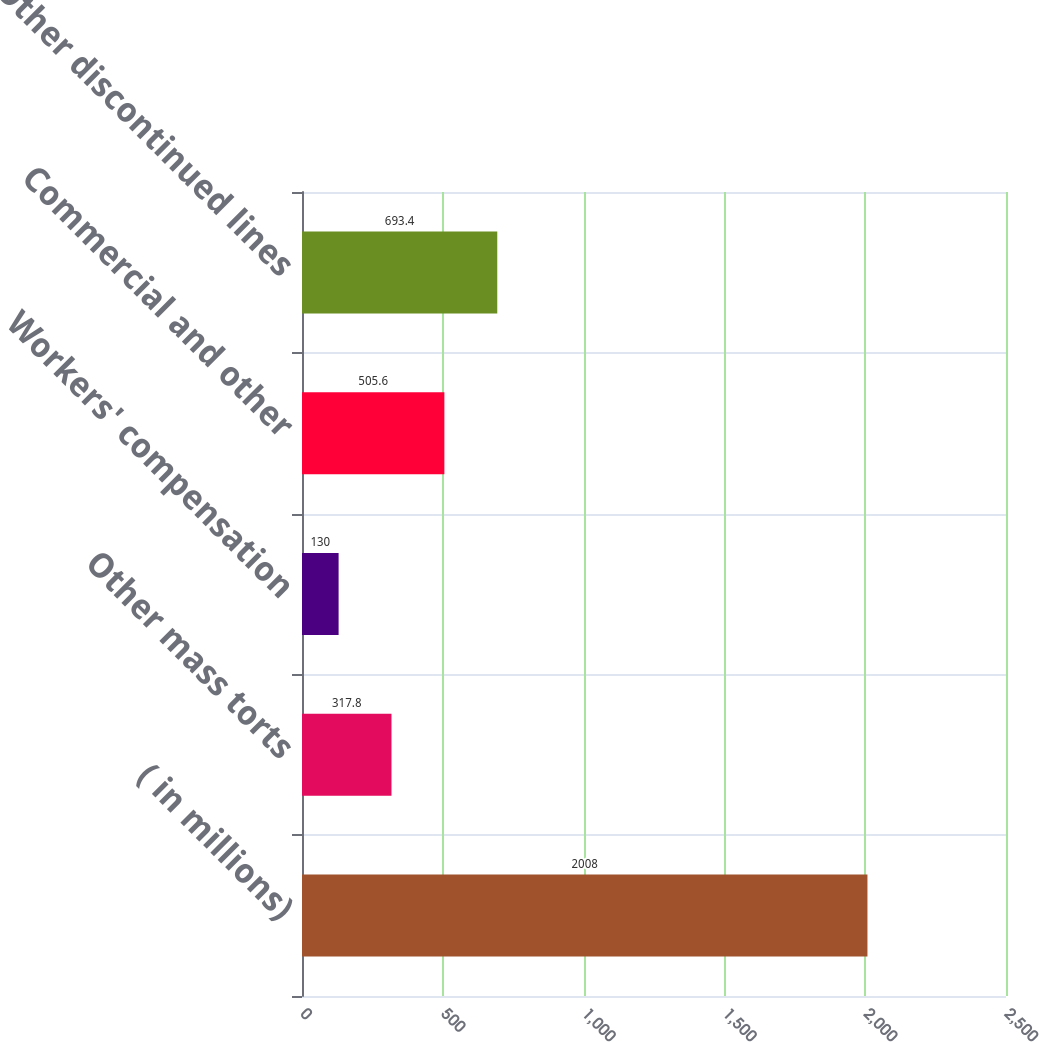Convert chart to OTSL. <chart><loc_0><loc_0><loc_500><loc_500><bar_chart><fcel>( in millions)<fcel>Other mass torts<fcel>Workers' compensation<fcel>Commercial and other<fcel>Other discontinued lines<nl><fcel>2008<fcel>317.8<fcel>130<fcel>505.6<fcel>693.4<nl></chart> 